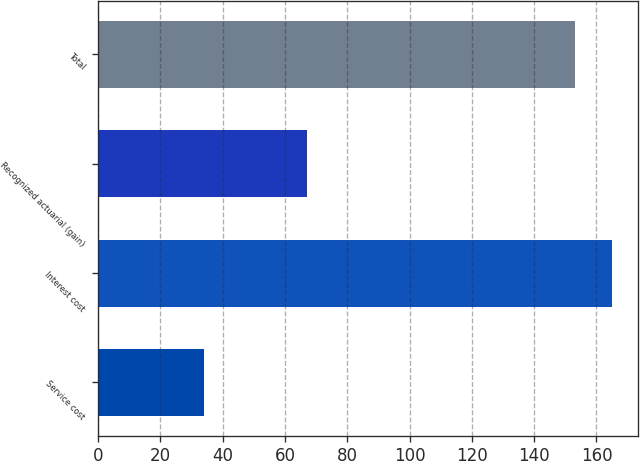<chart> <loc_0><loc_0><loc_500><loc_500><bar_chart><fcel>Service cost<fcel>Interest cost<fcel>Recognized actuarial (gain)<fcel>Total<nl><fcel>34<fcel>165<fcel>67<fcel>153<nl></chart> 